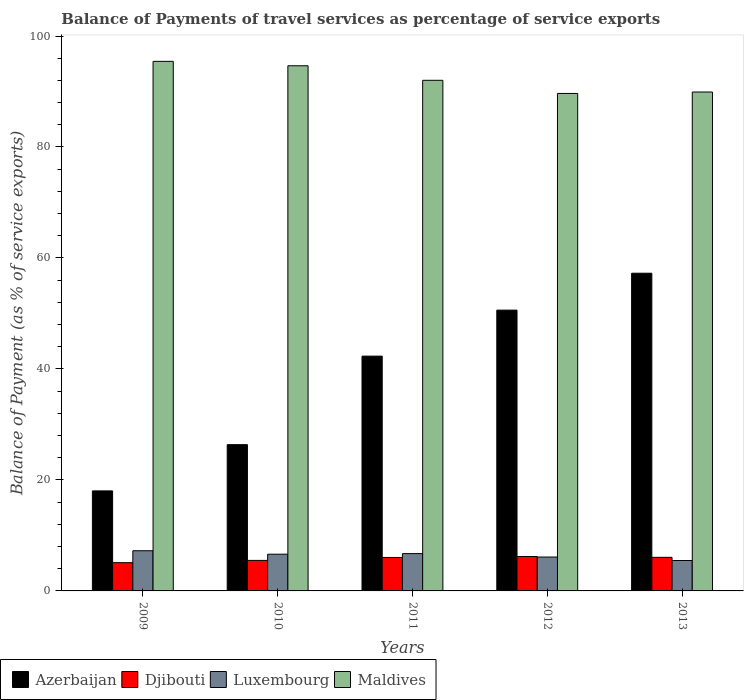How many different coloured bars are there?
Give a very brief answer. 4. How many groups of bars are there?
Offer a very short reply. 5. Are the number of bars on each tick of the X-axis equal?
Keep it short and to the point. Yes. In how many cases, is the number of bars for a given year not equal to the number of legend labels?
Ensure brevity in your answer.  0. What is the balance of payments of travel services in Luxembourg in 2010?
Ensure brevity in your answer.  6.62. Across all years, what is the maximum balance of payments of travel services in Luxembourg?
Give a very brief answer. 7.24. Across all years, what is the minimum balance of payments of travel services in Djibouti?
Give a very brief answer. 5.09. In which year was the balance of payments of travel services in Maldives maximum?
Your response must be concise. 2009. What is the total balance of payments of travel services in Maldives in the graph?
Offer a terse response. 461.65. What is the difference between the balance of payments of travel services in Djibouti in 2011 and that in 2013?
Your answer should be compact. -0.02. What is the difference between the balance of payments of travel services in Luxembourg in 2011 and the balance of payments of travel services in Djibouti in 2010?
Make the answer very short. 1.22. What is the average balance of payments of travel services in Azerbaijan per year?
Your answer should be compact. 38.91. In the year 2011, what is the difference between the balance of payments of travel services in Luxembourg and balance of payments of travel services in Maldives?
Make the answer very short. -85.3. In how many years, is the balance of payments of travel services in Azerbaijan greater than 88 %?
Your response must be concise. 0. What is the ratio of the balance of payments of travel services in Maldives in 2011 to that in 2012?
Provide a succinct answer. 1.03. Is the balance of payments of travel services in Djibouti in 2010 less than that in 2012?
Your response must be concise. Yes. Is the difference between the balance of payments of travel services in Luxembourg in 2010 and 2012 greater than the difference between the balance of payments of travel services in Maldives in 2010 and 2012?
Your answer should be compact. No. What is the difference between the highest and the second highest balance of payments of travel services in Djibouti?
Make the answer very short. 0.15. What is the difference between the highest and the lowest balance of payments of travel services in Djibouti?
Offer a very short reply. 1.11. Is the sum of the balance of payments of travel services in Maldives in 2009 and 2011 greater than the maximum balance of payments of travel services in Djibouti across all years?
Your response must be concise. Yes. What does the 2nd bar from the left in 2012 represents?
Your answer should be compact. Djibouti. What does the 3rd bar from the right in 2009 represents?
Keep it short and to the point. Djibouti. How many bars are there?
Provide a short and direct response. 20. Are all the bars in the graph horizontal?
Give a very brief answer. No. How many years are there in the graph?
Provide a short and direct response. 5. Are the values on the major ticks of Y-axis written in scientific E-notation?
Make the answer very short. No. Does the graph contain grids?
Your answer should be very brief. No. How many legend labels are there?
Make the answer very short. 4. What is the title of the graph?
Keep it short and to the point. Balance of Payments of travel services as percentage of service exports. Does "American Samoa" appear as one of the legend labels in the graph?
Your answer should be compact. No. What is the label or title of the X-axis?
Your answer should be very brief. Years. What is the label or title of the Y-axis?
Offer a terse response. Balance of Payment (as % of service exports). What is the Balance of Payment (as % of service exports) of Azerbaijan in 2009?
Provide a short and direct response. 18.02. What is the Balance of Payment (as % of service exports) in Djibouti in 2009?
Keep it short and to the point. 5.09. What is the Balance of Payment (as % of service exports) in Luxembourg in 2009?
Provide a succinct answer. 7.24. What is the Balance of Payment (as % of service exports) of Maldives in 2009?
Offer a terse response. 95.43. What is the Balance of Payment (as % of service exports) in Azerbaijan in 2010?
Make the answer very short. 26.36. What is the Balance of Payment (as % of service exports) in Djibouti in 2010?
Your answer should be compact. 5.5. What is the Balance of Payment (as % of service exports) in Luxembourg in 2010?
Ensure brevity in your answer.  6.62. What is the Balance of Payment (as % of service exports) in Maldives in 2010?
Ensure brevity in your answer.  94.64. What is the Balance of Payment (as % of service exports) of Azerbaijan in 2011?
Provide a succinct answer. 42.31. What is the Balance of Payment (as % of service exports) in Djibouti in 2011?
Your answer should be very brief. 6.03. What is the Balance of Payment (as % of service exports) of Luxembourg in 2011?
Provide a short and direct response. 6.72. What is the Balance of Payment (as % of service exports) in Maldives in 2011?
Your answer should be compact. 92.02. What is the Balance of Payment (as % of service exports) of Azerbaijan in 2012?
Make the answer very short. 50.6. What is the Balance of Payment (as % of service exports) in Djibouti in 2012?
Provide a short and direct response. 6.2. What is the Balance of Payment (as % of service exports) in Luxembourg in 2012?
Your answer should be very brief. 6.11. What is the Balance of Payment (as % of service exports) in Maldives in 2012?
Give a very brief answer. 89.65. What is the Balance of Payment (as % of service exports) in Azerbaijan in 2013?
Your answer should be very brief. 57.25. What is the Balance of Payment (as % of service exports) of Djibouti in 2013?
Your answer should be very brief. 6.05. What is the Balance of Payment (as % of service exports) of Luxembourg in 2013?
Your answer should be very brief. 5.48. What is the Balance of Payment (as % of service exports) of Maldives in 2013?
Provide a succinct answer. 89.91. Across all years, what is the maximum Balance of Payment (as % of service exports) in Azerbaijan?
Keep it short and to the point. 57.25. Across all years, what is the maximum Balance of Payment (as % of service exports) in Djibouti?
Offer a very short reply. 6.2. Across all years, what is the maximum Balance of Payment (as % of service exports) in Luxembourg?
Give a very brief answer. 7.24. Across all years, what is the maximum Balance of Payment (as % of service exports) in Maldives?
Your answer should be very brief. 95.43. Across all years, what is the minimum Balance of Payment (as % of service exports) in Azerbaijan?
Offer a terse response. 18.02. Across all years, what is the minimum Balance of Payment (as % of service exports) of Djibouti?
Offer a very short reply. 5.09. Across all years, what is the minimum Balance of Payment (as % of service exports) in Luxembourg?
Your answer should be very brief. 5.48. Across all years, what is the minimum Balance of Payment (as % of service exports) in Maldives?
Offer a terse response. 89.65. What is the total Balance of Payment (as % of service exports) of Azerbaijan in the graph?
Ensure brevity in your answer.  194.55. What is the total Balance of Payment (as % of service exports) of Djibouti in the graph?
Make the answer very short. 28.87. What is the total Balance of Payment (as % of service exports) in Luxembourg in the graph?
Keep it short and to the point. 32.17. What is the total Balance of Payment (as % of service exports) of Maldives in the graph?
Your answer should be very brief. 461.65. What is the difference between the Balance of Payment (as % of service exports) of Azerbaijan in 2009 and that in 2010?
Make the answer very short. -8.34. What is the difference between the Balance of Payment (as % of service exports) of Djibouti in 2009 and that in 2010?
Your answer should be compact. -0.41. What is the difference between the Balance of Payment (as % of service exports) of Luxembourg in 2009 and that in 2010?
Provide a short and direct response. 0.62. What is the difference between the Balance of Payment (as % of service exports) of Maldives in 2009 and that in 2010?
Your answer should be very brief. 0.8. What is the difference between the Balance of Payment (as % of service exports) in Azerbaijan in 2009 and that in 2011?
Provide a succinct answer. -24.29. What is the difference between the Balance of Payment (as % of service exports) of Djibouti in 2009 and that in 2011?
Provide a short and direct response. -0.94. What is the difference between the Balance of Payment (as % of service exports) of Luxembourg in 2009 and that in 2011?
Keep it short and to the point. 0.52. What is the difference between the Balance of Payment (as % of service exports) in Maldives in 2009 and that in 2011?
Your answer should be very brief. 3.42. What is the difference between the Balance of Payment (as % of service exports) of Azerbaijan in 2009 and that in 2012?
Ensure brevity in your answer.  -32.58. What is the difference between the Balance of Payment (as % of service exports) of Djibouti in 2009 and that in 2012?
Offer a terse response. -1.11. What is the difference between the Balance of Payment (as % of service exports) of Luxembourg in 2009 and that in 2012?
Keep it short and to the point. 1.13. What is the difference between the Balance of Payment (as % of service exports) of Maldives in 2009 and that in 2012?
Provide a succinct answer. 5.78. What is the difference between the Balance of Payment (as % of service exports) of Azerbaijan in 2009 and that in 2013?
Your response must be concise. -39.23. What is the difference between the Balance of Payment (as % of service exports) in Djibouti in 2009 and that in 2013?
Your answer should be very brief. -0.96. What is the difference between the Balance of Payment (as % of service exports) in Luxembourg in 2009 and that in 2013?
Ensure brevity in your answer.  1.76. What is the difference between the Balance of Payment (as % of service exports) of Maldives in 2009 and that in 2013?
Provide a succinct answer. 5.53. What is the difference between the Balance of Payment (as % of service exports) of Azerbaijan in 2010 and that in 2011?
Your answer should be very brief. -15.95. What is the difference between the Balance of Payment (as % of service exports) in Djibouti in 2010 and that in 2011?
Offer a terse response. -0.53. What is the difference between the Balance of Payment (as % of service exports) in Luxembourg in 2010 and that in 2011?
Keep it short and to the point. -0.1. What is the difference between the Balance of Payment (as % of service exports) in Maldives in 2010 and that in 2011?
Ensure brevity in your answer.  2.62. What is the difference between the Balance of Payment (as % of service exports) of Azerbaijan in 2010 and that in 2012?
Make the answer very short. -24.24. What is the difference between the Balance of Payment (as % of service exports) of Djibouti in 2010 and that in 2012?
Provide a short and direct response. -0.7. What is the difference between the Balance of Payment (as % of service exports) in Luxembourg in 2010 and that in 2012?
Ensure brevity in your answer.  0.51. What is the difference between the Balance of Payment (as % of service exports) of Maldives in 2010 and that in 2012?
Your answer should be very brief. 4.99. What is the difference between the Balance of Payment (as % of service exports) of Azerbaijan in 2010 and that in 2013?
Offer a very short reply. -30.89. What is the difference between the Balance of Payment (as % of service exports) of Djibouti in 2010 and that in 2013?
Make the answer very short. -0.55. What is the difference between the Balance of Payment (as % of service exports) of Luxembourg in 2010 and that in 2013?
Your response must be concise. 1.14. What is the difference between the Balance of Payment (as % of service exports) in Maldives in 2010 and that in 2013?
Your answer should be very brief. 4.73. What is the difference between the Balance of Payment (as % of service exports) in Azerbaijan in 2011 and that in 2012?
Ensure brevity in your answer.  -8.29. What is the difference between the Balance of Payment (as % of service exports) of Djibouti in 2011 and that in 2012?
Provide a succinct answer. -0.17. What is the difference between the Balance of Payment (as % of service exports) of Luxembourg in 2011 and that in 2012?
Your response must be concise. 0.62. What is the difference between the Balance of Payment (as % of service exports) of Maldives in 2011 and that in 2012?
Offer a terse response. 2.37. What is the difference between the Balance of Payment (as % of service exports) in Azerbaijan in 2011 and that in 2013?
Provide a succinct answer. -14.94. What is the difference between the Balance of Payment (as % of service exports) of Djibouti in 2011 and that in 2013?
Provide a short and direct response. -0.02. What is the difference between the Balance of Payment (as % of service exports) of Luxembourg in 2011 and that in 2013?
Provide a succinct answer. 1.24. What is the difference between the Balance of Payment (as % of service exports) of Maldives in 2011 and that in 2013?
Offer a terse response. 2.11. What is the difference between the Balance of Payment (as % of service exports) in Azerbaijan in 2012 and that in 2013?
Provide a succinct answer. -6.65. What is the difference between the Balance of Payment (as % of service exports) in Luxembourg in 2012 and that in 2013?
Your response must be concise. 0.62. What is the difference between the Balance of Payment (as % of service exports) of Maldives in 2012 and that in 2013?
Ensure brevity in your answer.  -0.26. What is the difference between the Balance of Payment (as % of service exports) of Azerbaijan in 2009 and the Balance of Payment (as % of service exports) of Djibouti in 2010?
Your response must be concise. 12.52. What is the difference between the Balance of Payment (as % of service exports) of Azerbaijan in 2009 and the Balance of Payment (as % of service exports) of Luxembourg in 2010?
Make the answer very short. 11.4. What is the difference between the Balance of Payment (as % of service exports) of Azerbaijan in 2009 and the Balance of Payment (as % of service exports) of Maldives in 2010?
Give a very brief answer. -76.61. What is the difference between the Balance of Payment (as % of service exports) of Djibouti in 2009 and the Balance of Payment (as % of service exports) of Luxembourg in 2010?
Your answer should be very brief. -1.53. What is the difference between the Balance of Payment (as % of service exports) of Djibouti in 2009 and the Balance of Payment (as % of service exports) of Maldives in 2010?
Your answer should be very brief. -89.55. What is the difference between the Balance of Payment (as % of service exports) in Luxembourg in 2009 and the Balance of Payment (as % of service exports) in Maldives in 2010?
Your response must be concise. -87.4. What is the difference between the Balance of Payment (as % of service exports) in Azerbaijan in 2009 and the Balance of Payment (as % of service exports) in Djibouti in 2011?
Your response must be concise. 11.99. What is the difference between the Balance of Payment (as % of service exports) of Azerbaijan in 2009 and the Balance of Payment (as % of service exports) of Luxembourg in 2011?
Offer a very short reply. 11.3. What is the difference between the Balance of Payment (as % of service exports) in Azerbaijan in 2009 and the Balance of Payment (as % of service exports) in Maldives in 2011?
Provide a succinct answer. -73.99. What is the difference between the Balance of Payment (as % of service exports) of Djibouti in 2009 and the Balance of Payment (as % of service exports) of Luxembourg in 2011?
Ensure brevity in your answer.  -1.63. What is the difference between the Balance of Payment (as % of service exports) of Djibouti in 2009 and the Balance of Payment (as % of service exports) of Maldives in 2011?
Provide a short and direct response. -86.93. What is the difference between the Balance of Payment (as % of service exports) in Luxembourg in 2009 and the Balance of Payment (as % of service exports) in Maldives in 2011?
Provide a succinct answer. -84.78. What is the difference between the Balance of Payment (as % of service exports) of Azerbaijan in 2009 and the Balance of Payment (as % of service exports) of Djibouti in 2012?
Keep it short and to the point. 11.82. What is the difference between the Balance of Payment (as % of service exports) in Azerbaijan in 2009 and the Balance of Payment (as % of service exports) in Luxembourg in 2012?
Provide a succinct answer. 11.92. What is the difference between the Balance of Payment (as % of service exports) of Azerbaijan in 2009 and the Balance of Payment (as % of service exports) of Maldives in 2012?
Give a very brief answer. -71.63. What is the difference between the Balance of Payment (as % of service exports) in Djibouti in 2009 and the Balance of Payment (as % of service exports) in Luxembourg in 2012?
Keep it short and to the point. -1.02. What is the difference between the Balance of Payment (as % of service exports) of Djibouti in 2009 and the Balance of Payment (as % of service exports) of Maldives in 2012?
Your answer should be compact. -84.56. What is the difference between the Balance of Payment (as % of service exports) in Luxembourg in 2009 and the Balance of Payment (as % of service exports) in Maldives in 2012?
Provide a succinct answer. -82.41. What is the difference between the Balance of Payment (as % of service exports) in Azerbaijan in 2009 and the Balance of Payment (as % of service exports) in Djibouti in 2013?
Your response must be concise. 11.97. What is the difference between the Balance of Payment (as % of service exports) in Azerbaijan in 2009 and the Balance of Payment (as % of service exports) in Luxembourg in 2013?
Your response must be concise. 12.54. What is the difference between the Balance of Payment (as % of service exports) in Azerbaijan in 2009 and the Balance of Payment (as % of service exports) in Maldives in 2013?
Provide a short and direct response. -71.89. What is the difference between the Balance of Payment (as % of service exports) in Djibouti in 2009 and the Balance of Payment (as % of service exports) in Luxembourg in 2013?
Keep it short and to the point. -0.39. What is the difference between the Balance of Payment (as % of service exports) in Djibouti in 2009 and the Balance of Payment (as % of service exports) in Maldives in 2013?
Your answer should be very brief. -84.82. What is the difference between the Balance of Payment (as % of service exports) of Luxembourg in 2009 and the Balance of Payment (as % of service exports) of Maldives in 2013?
Provide a short and direct response. -82.67. What is the difference between the Balance of Payment (as % of service exports) in Azerbaijan in 2010 and the Balance of Payment (as % of service exports) in Djibouti in 2011?
Give a very brief answer. 20.33. What is the difference between the Balance of Payment (as % of service exports) in Azerbaijan in 2010 and the Balance of Payment (as % of service exports) in Luxembourg in 2011?
Offer a terse response. 19.64. What is the difference between the Balance of Payment (as % of service exports) in Azerbaijan in 2010 and the Balance of Payment (as % of service exports) in Maldives in 2011?
Give a very brief answer. -65.66. What is the difference between the Balance of Payment (as % of service exports) in Djibouti in 2010 and the Balance of Payment (as % of service exports) in Luxembourg in 2011?
Your answer should be very brief. -1.22. What is the difference between the Balance of Payment (as % of service exports) in Djibouti in 2010 and the Balance of Payment (as % of service exports) in Maldives in 2011?
Give a very brief answer. -86.52. What is the difference between the Balance of Payment (as % of service exports) of Luxembourg in 2010 and the Balance of Payment (as % of service exports) of Maldives in 2011?
Keep it short and to the point. -85.4. What is the difference between the Balance of Payment (as % of service exports) of Azerbaijan in 2010 and the Balance of Payment (as % of service exports) of Djibouti in 2012?
Your response must be concise. 20.16. What is the difference between the Balance of Payment (as % of service exports) of Azerbaijan in 2010 and the Balance of Payment (as % of service exports) of Luxembourg in 2012?
Offer a very short reply. 20.26. What is the difference between the Balance of Payment (as % of service exports) in Azerbaijan in 2010 and the Balance of Payment (as % of service exports) in Maldives in 2012?
Offer a very short reply. -63.29. What is the difference between the Balance of Payment (as % of service exports) of Djibouti in 2010 and the Balance of Payment (as % of service exports) of Luxembourg in 2012?
Offer a very short reply. -0.6. What is the difference between the Balance of Payment (as % of service exports) in Djibouti in 2010 and the Balance of Payment (as % of service exports) in Maldives in 2012?
Your response must be concise. -84.15. What is the difference between the Balance of Payment (as % of service exports) in Luxembourg in 2010 and the Balance of Payment (as % of service exports) in Maldives in 2012?
Offer a very short reply. -83.03. What is the difference between the Balance of Payment (as % of service exports) of Azerbaijan in 2010 and the Balance of Payment (as % of service exports) of Djibouti in 2013?
Make the answer very short. 20.31. What is the difference between the Balance of Payment (as % of service exports) in Azerbaijan in 2010 and the Balance of Payment (as % of service exports) in Luxembourg in 2013?
Ensure brevity in your answer.  20.88. What is the difference between the Balance of Payment (as % of service exports) in Azerbaijan in 2010 and the Balance of Payment (as % of service exports) in Maldives in 2013?
Your response must be concise. -63.55. What is the difference between the Balance of Payment (as % of service exports) of Djibouti in 2010 and the Balance of Payment (as % of service exports) of Luxembourg in 2013?
Your answer should be very brief. 0.02. What is the difference between the Balance of Payment (as % of service exports) in Djibouti in 2010 and the Balance of Payment (as % of service exports) in Maldives in 2013?
Offer a terse response. -84.41. What is the difference between the Balance of Payment (as % of service exports) in Luxembourg in 2010 and the Balance of Payment (as % of service exports) in Maldives in 2013?
Offer a very short reply. -83.29. What is the difference between the Balance of Payment (as % of service exports) in Azerbaijan in 2011 and the Balance of Payment (as % of service exports) in Djibouti in 2012?
Provide a short and direct response. 36.11. What is the difference between the Balance of Payment (as % of service exports) of Azerbaijan in 2011 and the Balance of Payment (as % of service exports) of Luxembourg in 2012?
Give a very brief answer. 36.21. What is the difference between the Balance of Payment (as % of service exports) of Azerbaijan in 2011 and the Balance of Payment (as % of service exports) of Maldives in 2012?
Provide a succinct answer. -47.34. What is the difference between the Balance of Payment (as % of service exports) in Djibouti in 2011 and the Balance of Payment (as % of service exports) in Luxembourg in 2012?
Make the answer very short. -0.08. What is the difference between the Balance of Payment (as % of service exports) in Djibouti in 2011 and the Balance of Payment (as % of service exports) in Maldives in 2012?
Ensure brevity in your answer.  -83.62. What is the difference between the Balance of Payment (as % of service exports) in Luxembourg in 2011 and the Balance of Payment (as % of service exports) in Maldives in 2012?
Ensure brevity in your answer.  -82.93. What is the difference between the Balance of Payment (as % of service exports) of Azerbaijan in 2011 and the Balance of Payment (as % of service exports) of Djibouti in 2013?
Ensure brevity in your answer.  36.26. What is the difference between the Balance of Payment (as % of service exports) of Azerbaijan in 2011 and the Balance of Payment (as % of service exports) of Luxembourg in 2013?
Your answer should be very brief. 36.83. What is the difference between the Balance of Payment (as % of service exports) of Azerbaijan in 2011 and the Balance of Payment (as % of service exports) of Maldives in 2013?
Offer a very short reply. -47.6. What is the difference between the Balance of Payment (as % of service exports) of Djibouti in 2011 and the Balance of Payment (as % of service exports) of Luxembourg in 2013?
Your answer should be compact. 0.55. What is the difference between the Balance of Payment (as % of service exports) of Djibouti in 2011 and the Balance of Payment (as % of service exports) of Maldives in 2013?
Your answer should be compact. -83.88. What is the difference between the Balance of Payment (as % of service exports) of Luxembourg in 2011 and the Balance of Payment (as % of service exports) of Maldives in 2013?
Make the answer very short. -83.19. What is the difference between the Balance of Payment (as % of service exports) in Azerbaijan in 2012 and the Balance of Payment (as % of service exports) in Djibouti in 2013?
Make the answer very short. 44.55. What is the difference between the Balance of Payment (as % of service exports) of Azerbaijan in 2012 and the Balance of Payment (as % of service exports) of Luxembourg in 2013?
Give a very brief answer. 45.12. What is the difference between the Balance of Payment (as % of service exports) in Azerbaijan in 2012 and the Balance of Payment (as % of service exports) in Maldives in 2013?
Offer a very short reply. -39.31. What is the difference between the Balance of Payment (as % of service exports) of Djibouti in 2012 and the Balance of Payment (as % of service exports) of Luxembourg in 2013?
Keep it short and to the point. 0.72. What is the difference between the Balance of Payment (as % of service exports) of Djibouti in 2012 and the Balance of Payment (as % of service exports) of Maldives in 2013?
Make the answer very short. -83.71. What is the difference between the Balance of Payment (as % of service exports) of Luxembourg in 2012 and the Balance of Payment (as % of service exports) of Maldives in 2013?
Make the answer very short. -83.8. What is the average Balance of Payment (as % of service exports) in Azerbaijan per year?
Offer a terse response. 38.91. What is the average Balance of Payment (as % of service exports) of Djibouti per year?
Keep it short and to the point. 5.77. What is the average Balance of Payment (as % of service exports) of Luxembourg per year?
Ensure brevity in your answer.  6.43. What is the average Balance of Payment (as % of service exports) in Maldives per year?
Your answer should be compact. 92.33. In the year 2009, what is the difference between the Balance of Payment (as % of service exports) of Azerbaijan and Balance of Payment (as % of service exports) of Djibouti?
Give a very brief answer. 12.94. In the year 2009, what is the difference between the Balance of Payment (as % of service exports) in Azerbaijan and Balance of Payment (as % of service exports) in Luxembourg?
Offer a very short reply. 10.78. In the year 2009, what is the difference between the Balance of Payment (as % of service exports) of Azerbaijan and Balance of Payment (as % of service exports) of Maldives?
Provide a succinct answer. -77.41. In the year 2009, what is the difference between the Balance of Payment (as % of service exports) of Djibouti and Balance of Payment (as % of service exports) of Luxembourg?
Provide a succinct answer. -2.15. In the year 2009, what is the difference between the Balance of Payment (as % of service exports) of Djibouti and Balance of Payment (as % of service exports) of Maldives?
Offer a terse response. -90.35. In the year 2009, what is the difference between the Balance of Payment (as % of service exports) of Luxembourg and Balance of Payment (as % of service exports) of Maldives?
Your answer should be very brief. -88.19. In the year 2010, what is the difference between the Balance of Payment (as % of service exports) of Azerbaijan and Balance of Payment (as % of service exports) of Djibouti?
Provide a short and direct response. 20.86. In the year 2010, what is the difference between the Balance of Payment (as % of service exports) of Azerbaijan and Balance of Payment (as % of service exports) of Luxembourg?
Your answer should be compact. 19.74. In the year 2010, what is the difference between the Balance of Payment (as % of service exports) in Azerbaijan and Balance of Payment (as % of service exports) in Maldives?
Provide a short and direct response. -68.28. In the year 2010, what is the difference between the Balance of Payment (as % of service exports) in Djibouti and Balance of Payment (as % of service exports) in Luxembourg?
Your answer should be compact. -1.12. In the year 2010, what is the difference between the Balance of Payment (as % of service exports) in Djibouti and Balance of Payment (as % of service exports) in Maldives?
Provide a short and direct response. -89.14. In the year 2010, what is the difference between the Balance of Payment (as % of service exports) in Luxembourg and Balance of Payment (as % of service exports) in Maldives?
Give a very brief answer. -88.02. In the year 2011, what is the difference between the Balance of Payment (as % of service exports) in Azerbaijan and Balance of Payment (as % of service exports) in Djibouti?
Give a very brief answer. 36.28. In the year 2011, what is the difference between the Balance of Payment (as % of service exports) in Azerbaijan and Balance of Payment (as % of service exports) in Luxembourg?
Give a very brief answer. 35.59. In the year 2011, what is the difference between the Balance of Payment (as % of service exports) of Azerbaijan and Balance of Payment (as % of service exports) of Maldives?
Your answer should be compact. -49.71. In the year 2011, what is the difference between the Balance of Payment (as % of service exports) in Djibouti and Balance of Payment (as % of service exports) in Luxembourg?
Give a very brief answer. -0.69. In the year 2011, what is the difference between the Balance of Payment (as % of service exports) of Djibouti and Balance of Payment (as % of service exports) of Maldives?
Provide a short and direct response. -85.99. In the year 2011, what is the difference between the Balance of Payment (as % of service exports) in Luxembourg and Balance of Payment (as % of service exports) in Maldives?
Your answer should be very brief. -85.3. In the year 2012, what is the difference between the Balance of Payment (as % of service exports) in Azerbaijan and Balance of Payment (as % of service exports) in Djibouti?
Offer a very short reply. 44.4. In the year 2012, what is the difference between the Balance of Payment (as % of service exports) in Azerbaijan and Balance of Payment (as % of service exports) in Luxembourg?
Provide a short and direct response. 44.5. In the year 2012, what is the difference between the Balance of Payment (as % of service exports) of Azerbaijan and Balance of Payment (as % of service exports) of Maldives?
Offer a very short reply. -39.05. In the year 2012, what is the difference between the Balance of Payment (as % of service exports) in Djibouti and Balance of Payment (as % of service exports) in Luxembourg?
Your response must be concise. 0.1. In the year 2012, what is the difference between the Balance of Payment (as % of service exports) of Djibouti and Balance of Payment (as % of service exports) of Maldives?
Offer a very short reply. -83.45. In the year 2012, what is the difference between the Balance of Payment (as % of service exports) of Luxembourg and Balance of Payment (as % of service exports) of Maldives?
Your response must be concise. -83.55. In the year 2013, what is the difference between the Balance of Payment (as % of service exports) of Azerbaijan and Balance of Payment (as % of service exports) of Djibouti?
Ensure brevity in your answer.  51.2. In the year 2013, what is the difference between the Balance of Payment (as % of service exports) in Azerbaijan and Balance of Payment (as % of service exports) in Luxembourg?
Provide a short and direct response. 51.77. In the year 2013, what is the difference between the Balance of Payment (as % of service exports) in Azerbaijan and Balance of Payment (as % of service exports) in Maldives?
Your response must be concise. -32.66. In the year 2013, what is the difference between the Balance of Payment (as % of service exports) in Djibouti and Balance of Payment (as % of service exports) in Luxembourg?
Your answer should be compact. 0.57. In the year 2013, what is the difference between the Balance of Payment (as % of service exports) of Djibouti and Balance of Payment (as % of service exports) of Maldives?
Make the answer very short. -83.86. In the year 2013, what is the difference between the Balance of Payment (as % of service exports) of Luxembourg and Balance of Payment (as % of service exports) of Maldives?
Make the answer very short. -84.43. What is the ratio of the Balance of Payment (as % of service exports) in Azerbaijan in 2009 to that in 2010?
Provide a short and direct response. 0.68. What is the ratio of the Balance of Payment (as % of service exports) of Djibouti in 2009 to that in 2010?
Your answer should be compact. 0.93. What is the ratio of the Balance of Payment (as % of service exports) in Luxembourg in 2009 to that in 2010?
Give a very brief answer. 1.09. What is the ratio of the Balance of Payment (as % of service exports) in Maldives in 2009 to that in 2010?
Your answer should be very brief. 1.01. What is the ratio of the Balance of Payment (as % of service exports) in Azerbaijan in 2009 to that in 2011?
Your response must be concise. 0.43. What is the ratio of the Balance of Payment (as % of service exports) of Djibouti in 2009 to that in 2011?
Offer a very short reply. 0.84. What is the ratio of the Balance of Payment (as % of service exports) in Luxembourg in 2009 to that in 2011?
Give a very brief answer. 1.08. What is the ratio of the Balance of Payment (as % of service exports) in Maldives in 2009 to that in 2011?
Provide a succinct answer. 1.04. What is the ratio of the Balance of Payment (as % of service exports) in Azerbaijan in 2009 to that in 2012?
Your response must be concise. 0.36. What is the ratio of the Balance of Payment (as % of service exports) of Djibouti in 2009 to that in 2012?
Give a very brief answer. 0.82. What is the ratio of the Balance of Payment (as % of service exports) in Luxembourg in 2009 to that in 2012?
Provide a short and direct response. 1.19. What is the ratio of the Balance of Payment (as % of service exports) in Maldives in 2009 to that in 2012?
Offer a terse response. 1.06. What is the ratio of the Balance of Payment (as % of service exports) of Azerbaijan in 2009 to that in 2013?
Keep it short and to the point. 0.31. What is the ratio of the Balance of Payment (as % of service exports) in Djibouti in 2009 to that in 2013?
Your response must be concise. 0.84. What is the ratio of the Balance of Payment (as % of service exports) in Luxembourg in 2009 to that in 2013?
Provide a short and direct response. 1.32. What is the ratio of the Balance of Payment (as % of service exports) in Maldives in 2009 to that in 2013?
Provide a succinct answer. 1.06. What is the ratio of the Balance of Payment (as % of service exports) in Azerbaijan in 2010 to that in 2011?
Offer a terse response. 0.62. What is the ratio of the Balance of Payment (as % of service exports) of Djibouti in 2010 to that in 2011?
Provide a succinct answer. 0.91. What is the ratio of the Balance of Payment (as % of service exports) in Luxembourg in 2010 to that in 2011?
Provide a succinct answer. 0.98. What is the ratio of the Balance of Payment (as % of service exports) in Maldives in 2010 to that in 2011?
Your answer should be compact. 1.03. What is the ratio of the Balance of Payment (as % of service exports) in Azerbaijan in 2010 to that in 2012?
Ensure brevity in your answer.  0.52. What is the ratio of the Balance of Payment (as % of service exports) in Djibouti in 2010 to that in 2012?
Your answer should be very brief. 0.89. What is the ratio of the Balance of Payment (as % of service exports) of Luxembourg in 2010 to that in 2012?
Offer a very short reply. 1.08. What is the ratio of the Balance of Payment (as % of service exports) in Maldives in 2010 to that in 2012?
Your answer should be compact. 1.06. What is the ratio of the Balance of Payment (as % of service exports) in Azerbaijan in 2010 to that in 2013?
Provide a succinct answer. 0.46. What is the ratio of the Balance of Payment (as % of service exports) in Djibouti in 2010 to that in 2013?
Provide a succinct answer. 0.91. What is the ratio of the Balance of Payment (as % of service exports) in Luxembourg in 2010 to that in 2013?
Your response must be concise. 1.21. What is the ratio of the Balance of Payment (as % of service exports) in Maldives in 2010 to that in 2013?
Your response must be concise. 1.05. What is the ratio of the Balance of Payment (as % of service exports) of Azerbaijan in 2011 to that in 2012?
Provide a short and direct response. 0.84. What is the ratio of the Balance of Payment (as % of service exports) of Djibouti in 2011 to that in 2012?
Make the answer very short. 0.97. What is the ratio of the Balance of Payment (as % of service exports) in Luxembourg in 2011 to that in 2012?
Ensure brevity in your answer.  1.1. What is the ratio of the Balance of Payment (as % of service exports) in Maldives in 2011 to that in 2012?
Provide a short and direct response. 1.03. What is the ratio of the Balance of Payment (as % of service exports) of Azerbaijan in 2011 to that in 2013?
Offer a very short reply. 0.74. What is the ratio of the Balance of Payment (as % of service exports) of Luxembourg in 2011 to that in 2013?
Offer a very short reply. 1.23. What is the ratio of the Balance of Payment (as % of service exports) in Maldives in 2011 to that in 2013?
Ensure brevity in your answer.  1.02. What is the ratio of the Balance of Payment (as % of service exports) in Azerbaijan in 2012 to that in 2013?
Ensure brevity in your answer.  0.88. What is the ratio of the Balance of Payment (as % of service exports) in Djibouti in 2012 to that in 2013?
Give a very brief answer. 1.02. What is the ratio of the Balance of Payment (as % of service exports) in Luxembourg in 2012 to that in 2013?
Your answer should be compact. 1.11. What is the ratio of the Balance of Payment (as % of service exports) in Maldives in 2012 to that in 2013?
Your answer should be compact. 1. What is the difference between the highest and the second highest Balance of Payment (as % of service exports) of Azerbaijan?
Your response must be concise. 6.65. What is the difference between the highest and the second highest Balance of Payment (as % of service exports) of Djibouti?
Provide a short and direct response. 0.15. What is the difference between the highest and the second highest Balance of Payment (as % of service exports) in Luxembourg?
Your answer should be compact. 0.52. What is the difference between the highest and the second highest Balance of Payment (as % of service exports) of Maldives?
Provide a short and direct response. 0.8. What is the difference between the highest and the lowest Balance of Payment (as % of service exports) in Azerbaijan?
Your answer should be very brief. 39.23. What is the difference between the highest and the lowest Balance of Payment (as % of service exports) of Djibouti?
Provide a short and direct response. 1.11. What is the difference between the highest and the lowest Balance of Payment (as % of service exports) in Luxembourg?
Offer a terse response. 1.76. What is the difference between the highest and the lowest Balance of Payment (as % of service exports) in Maldives?
Provide a succinct answer. 5.78. 